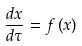<formula> <loc_0><loc_0><loc_500><loc_500>\frac { d x } { d \tau } = f \left ( x \right )</formula> 